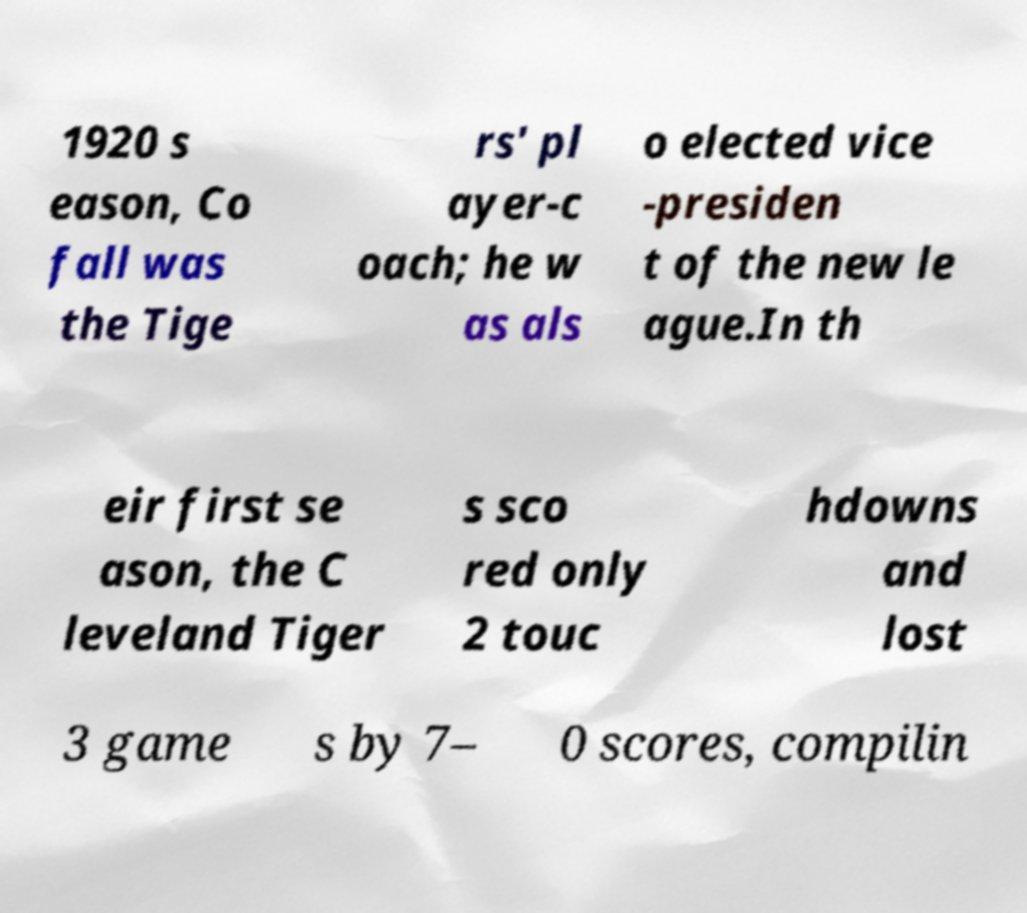There's text embedded in this image that I need extracted. Can you transcribe it verbatim? 1920 s eason, Co fall was the Tige rs' pl ayer-c oach; he w as als o elected vice -presiden t of the new le ague.In th eir first se ason, the C leveland Tiger s sco red only 2 touc hdowns and lost 3 game s by 7– 0 scores, compilin 